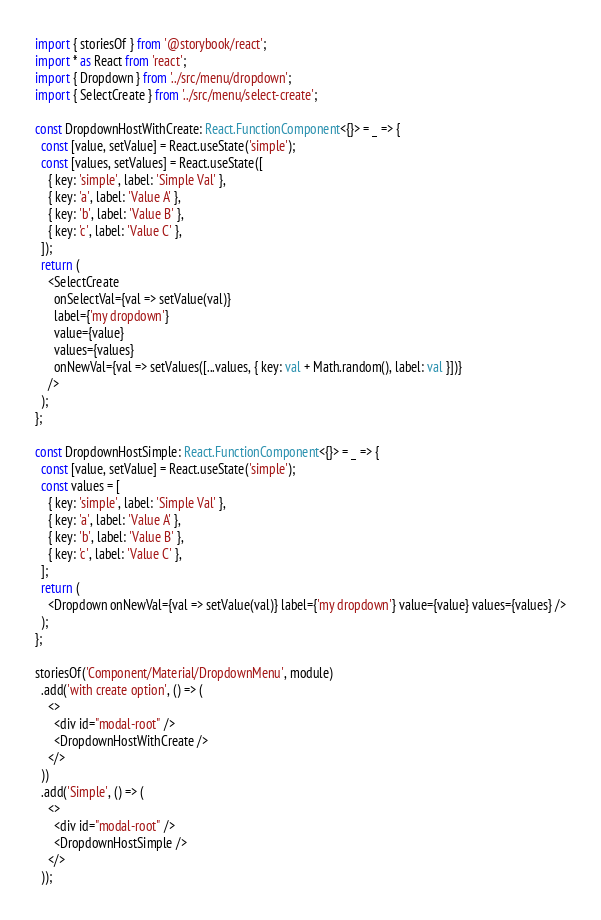Convert code to text. <code><loc_0><loc_0><loc_500><loc_500><_TypeScript_>import { storiesOf } from '@storybook/react';
import * as React from 'react';
import { Dropdown } from '../src/menu/dropdown';
import { SelectCreate } from '../src/menu/select-create';

const DropdownHostWithCreate: React.FunctionComponent<{}> = _ => {
  const [value, setValue] = React.useState('simple');
  const [values, setValues] = React.useState([
    { key: 'simple', label: 'Simple Val' },
    { key: 'a', label: 'Value A' },
    { key: 'b', label: 'Value B' },
    { key: 'c', label: 'Value C' },
  ]);
  return (
    <SelectCreate
      onSelectVal={val => setValue(val)}
      label={'my dropdown'}
      value={value}
      values={values}
      onNewVal={val => setValues([...values, { key: val + Math.random(), label: val }])}
    />
  );
};

const DropdownHostSimple: React.FunctionComponent<{}> = _ => {
  const [value, setValue] = React.useState('simple');
  const values = [
    { key: 'simple', label: 'Simple Val' },
    { key: 'a', label: 'Value A' },
    { key: 'b', label: 'Value B' },
    { key: 'c', label: 'Value C' },
  ];
  return (
    <Dropdown onNewVal={val => setValue(val)} label={'my dropdown'} value={value} values={values} />
  );
};

storiesOf('Component/Material/DropdownMenu', module)
  .add('with create option', () => (
    <>
      <div id="modal-root" />
      <DropdownHostWithCreate />
    </>
  ))
  .add('Simple', () => (
    <>
      <div id="modal-root" />
      <DropdownHostSimple />
    </>
  ));
</code> 